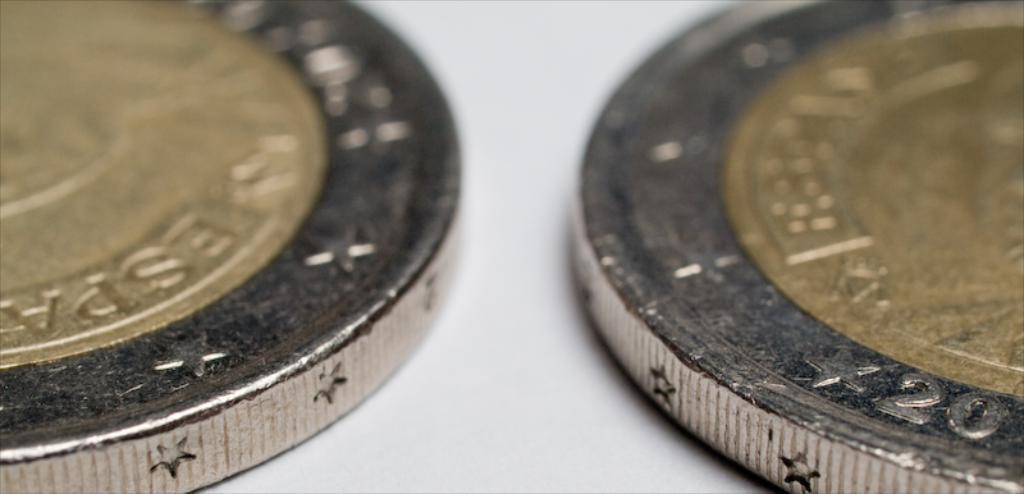What number is on the coin on right?
Provide a short and direct response. 20. 